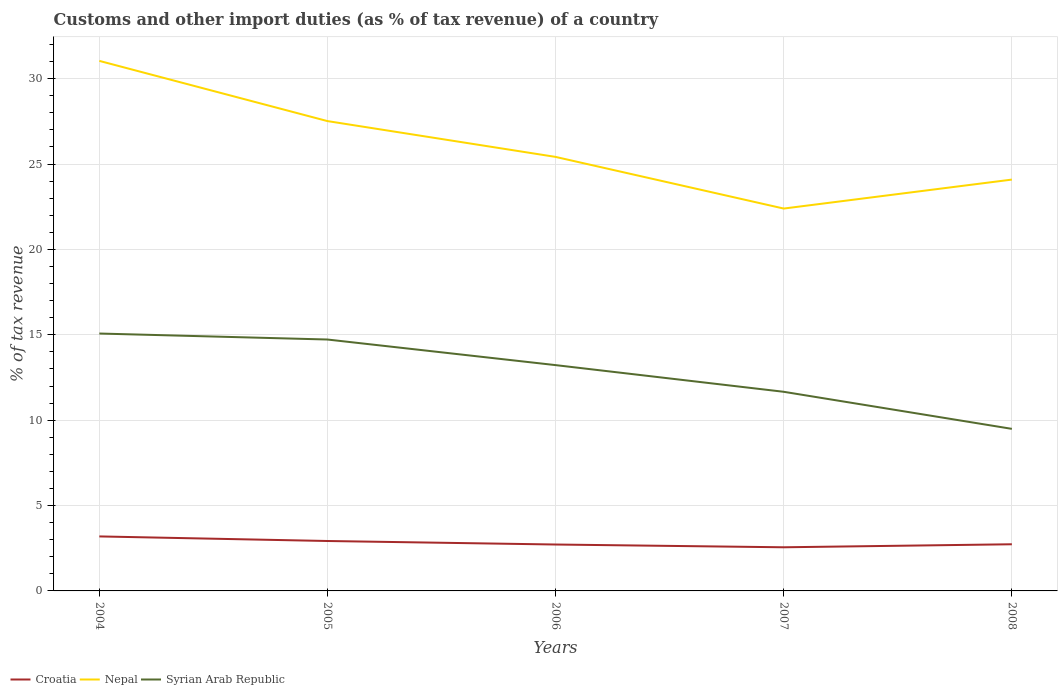Across all years, what is the maximum percentage of tax revenue from customs in Syrian Arab Republic?
Offer a terse response. 9.49. What is the total percentage of tax revenue from customs in Croatia in the graph?
Offer a terse response. 0.16. What is the difference between the highest and the second highest percentage of tax revenue from customs in Nepal?
Your answer should be very brief. 8.65. What is the difference between the highest and the lowest percentage of tax revenue from customs in Croatia?
Make the answer very short. 2. Is the percentage of tax revenue from customs in Croatia strictly greater than the percentage of tax revenue from customs in Nepal over the years?
Provide a short and direct response. Yes. What is the difference between two consecutive major ticks on the Y-axis?
Offer a terse response. 5. Are the values on the major ticks of Y-axis written in scientific E-notation?
Provide a short and direct response. No. Does the graph contain grids?
Offer a very short reply. Yes. How many legend labels are there?
Your response must be concise. 3. How are the legend labels stacked?
Offer a very short reply. Horizontal. What is the title of the graph?
Offer a terse response. Customs and other import duties (as % of tax revenue) of a country. Does "High income: nonOECD" appear as one of the legend labels in the graph?
Make the answer very short. No. What is the label or title of the Y-axis?
Make the answer very short. % of tax revenue. What is the % of tax revenue of Croatia in 2004?
Your response must be concise. 3.19. What is the % of tax revenue in Nepal in 2004?
Your answer should be very brief. 31.04. What is the % of tax revenue of Syrian Arab Republic in 2004?
Keep it short and to the point. 15.08. What is the % of tax revenue of Croatia in 2005?
Your answer should be very brief. 2.92. What is the % of tax revenue of Nepal in 2005?
Keep it short and to the point. 27.52. What is the % of tax revenue of Syrian Arab Republic in 2005?
Give a very brief answer. 14.72. What is the % of tax revenue in Croatia in 2006?
Provide a short and direct response. 2.72. What is the % of tax revenue of Nepal in 2006?
Your response must be concise. 25.42. What is the % of tax revenue of Syrian Arab Republic in 2006?
Offer a terse response. 13.22. What is the % of tax revenue in Croatia in 2007?
Offer a terse response. 2.56. What is the % of tax revenue in Nepal in 2007?
Your response must be concise. 22.39. What is the % of tax revenue of Syrian Arab Republic in 2007?
Your answer should be compact. 11.66. What is the % of tax revenue in Croatia in 2008?
Offer a terse response. 2.73. What is the % of tax revenue in Nepal in 2008?
Offer a terse response. 24.09. What is the % of tax revenue of Syrian Arab Republic in 2008?
Your answer should be very brief. 9.49. Across all years, what is the maximum % of tax revenue in Croatia?
Ensure brevity in your answer.  3.19. Across all years, what is the maximum % of tax revenue of Nepal?
Your answer should be compact. 31.04. Across all years, what is the maximum % of tax revenue in Syrian Arab Republic?
Keep it short and to the point. 15.08. Across all years, what is the minimum % of tax revenue in Croatia?
Provide a short and direct response. 2.56. Across all years, what is the minimum % of tax revenue of Nepal?
Your response must be concise. 22.39. Across all years, what is the minimum % of tax revenue of Syrian Arab Republic?
Offer a terse response. 9.49. What is the total % of tax revenue of Croatia in the graph?
Offer a terse response. 14.12. What is the total % of tax revenue of Nepal in the graph?
Your answer should be very brief. 130.47. What is the total % of tax revenue in Syrian Arab Republic in the graph?
Give a very brief answer. 64.18. What is the difference between the % of tax revenue of Croatia in 2004 and that in 2005?
Provide a succinct answer. 0.27. What is the difference between the % of tax revenue in Nepal in 2004 and that in 2005?
Ensure brevity in your answer.  3.53. What is the difference between the % of tax revenue of Syrian Arab Republic in 2004 and that in 2005?
Your response must be concise. 0.35. What is the difference between the % of tax revenue of Croatia in 2004 and that in 2006?
Provide a short and direct response. 0.47. What is the difference between the % of tax revenue of Nepal in 2004 and that in 2006?
Keep it short and to the point. 5.62. What is the difference between the % of tax revenue of Syrian Arab Republic in 2004 and that in 2006?
Your response must be concise. 1.85. What is the difference between the % of tax revenue of Croatia in 2004 and that in 2007?
Keep it short and to the point. 0.64. What is the difference between the % of tax revenue of Nepal in 2004 and that in 2007?
Offer a terse response. 8.65. What is the difference between the % of tax revenue of Syrian Arab Republic in 2004 and that in 2007?
Your answer should be compact. 3.41. What is the difference between the % of tax revenue of Croatia in 2004 and that in 2008?
Keep it short and to the point. 0.46. What is the difference between the % of tax revenue of Nepal in 2004 and that in 2008?
Make the answer very short. 6.95. What is the difference between the % of tax revenue in Syrian Arab Republic in 2004 and that in 2008?
Provide a short and direct response. 5.58. What is the difference between the % of tax revenue in Croatia in 2005 and that in 2006?
Ensure brevity in your answer.  0.21. What is the difference between the % of tax revenue in Nepal in 2005 and that in 2006?
Provide a short and direct response. 2.1. What is the difference between the % of tax revenue of Syrian Arab Republic in 2005 and that in 2006?
Provide a short and direct response. 1.5. What is the difference between the % of tax revenue in Croatia in 2005 and that in 2007?
Provide a short and direct response. 0.37. What is the difference between the % of tax revenue in Nepal in 2005 and that in 2007?
Keep it short and to the point. 5.12. What is the difference between the % of tax revenue in Syrian Arab Republic in 2005 and that in 2007?
Offer a terse response. 3.06. What is the difference between the % of tax revenue in Croatia in 2005 and that in 2008?
Your response must be concise. 0.19. What is the difference between the % of tax revenue in Nepal in 2005 and that in 2008?
Offer a very short reply. 3.43. What is the difference between the % of tax revenue in Syrian Arab Republic in 2005 and that in 2008?
Provide a succinct answer. 5.23. What is the difference between the % of tax revenue of Croatia in 2006 and that in 2007?
Offer a terse response. 0.16. What is the difference between the % of tax revenue in Nepal in 2006 and that in 2007?
Provide a short and direct response. 3.02. What is the difference between the % of tax revenue in Syrian Arab Republic in 2006 and that in 2007?
Offer a terse response. 1.56. What is the difference between the % of tax revenue of Croatia in 2006 and that in 2008?
Make the answer very short. -0.01. What is the difference between the % of tax revenue in Nepal in 2006 and that in 2008?
Provide a short and direct response. 1.33. What is the difference between the % of tax revenue in Syrian Arab Republic in 2006 and that in 2008?
Make the answer very short. 3.73. What is the difference between the % of tax revenue of Croatia in 2007 and that in 2008?
Your answer should be very brief. -0.18. What is the difference between the % of tax revenue in Nepal in 2007 and that in 2008?
Keep it short and to the point. -1.7. What is the difference between the % of tax revenue in Syrian Arab Republic in 2007 and that in 2008?
Give a very brief answer. 2.17. What is the difference between the % of tax revenue in Croatia in 2004 and the % of tax revenue in Nepal in 2005?
Your response must be concise. -24.33. What is the difference between the % of tax revenue of Croatia in 2004 and the % of tax revenue of Syrian Arab Republic in 2005?
Your response must be concise. -11.53. What is the difference between the % of tax revenue of Nepal in 2004 and the % of tax revenue of Syrian Arab Republic in 2005?
Ensure brevity in your answer.  16.32. What is the difference between the % of tax revenue in Croatia in 2004 and the % of tax revenue in Nepal in 2006?
Your answer should be very brief. -22.23. What is the difference between the % of tax revenue of Croatia in 2004 and the % of tax revenue of Syrian Arab Republic in 2006?
Give a very brief answer. -10.03. What is the difference between the % of tax revenue in Nepal in 2004 and the % of tax revenue in Syrian Arab Republic in 2006?
Make the answer very short. 17.82. What is the difference between the % of tax revenue in Croatia in 2004 and the % of tax revenue in Nepal in 2007?
Provide a succinct answer. -19.2. What is the difference between the % of tax revenue of Croatia in 2004 and the % of tax revenue of Syrian Arab Republic in 2007?
Provide a short and direct response. -8.47. What is the difference between the % of tax revenue in Nepal in 2004 and the % of tax revenue in Syrian Arab Republic in 2007?
Offer a terse response. 19.38. What is the difference between the % of tax revenue of Croatia in 2004 and the % of tax revenue of Nepal in 2008?
Your answer should be very brief. -20.9. What is the difference between the % of tax revenue in Croatia in 2004 and the % of tax revenue in Syrian Arab Republic in 2008?
Your response must be concise. -6.3. What is the difference between the % of tax revenue in Nepal in 2004 and the % of tax revenue in Syrian Arab Republic in 2008?
Make the answer very short. 21.55. What is the difference between the % of tax revenue in Croatia in 2005 and the % of tax revenue in Nepal in 2006?
Your answer should be compact. -22.5. What is the difference between the % of tax revenue in Croatia in 2005 and the % of tax revenue in Syrian Arab Republic in 2006?
Your response must be concise. -10.3. What is the difference between the % of tax revenue in Nepal in 2005 and the % of tax revenue in Syrian Arab Republic in 2006?
Keep it short and to the point. 14.29. What is the difference between the % of tax revenue in Croatia in 2005 and the % of tax revenue in Nepal in 2007?
Provide a succinct answer. -19.47. What is the difference between the % of tax revenue of Croatia in 2005 and the % of tax revenue of Syrian Arab Republic in 2007?
Offer a terse response. -8.74. What is the difference between the % of tax revenue of Nepal in 2005 and the % of tax revenue of Syrian Arab Republic in 2007?
Give a very brief answer. 15.85. What is the difference between the % of tax revenue in Croatia in 2005 and the % of tax revenue in Nepal in 2008?
Offer a terse response. -21.17. What is the difference between the % of tax revenue in Croatia in 2005 and the % of tax revenue in Syrian Arab Republic in 2008?
Provide a succinct answer. -6.57. What is the difference between the % of tax revenue of Nepal in 2005 and the % of tax revenue of Syrian Arab Republic in 2008?
Provide a short and direct response. 18.03. What is the difference between the % of tax revenue of Croatia in 2006 and the % of tax revenue of Nepal in 2007?
Give a very brief answer. -19.68. What is the difference between the % of tax revenue of Croatia in 2006 and the % of tax revenue of Syrian Arab Republic in 2007?
Your answer should be compact. -8.95. What is the difference between the % of tax revenue in Nepal in 2006 and the % of tax revenue in Syrian Arab Republic in 2007?
Provide a succinct answer. 13.76. What is the difference between the % of tax revenue of Croatia in 2006 and the % of tax revenue of Nepal in 2008?
Give a very brief answer. -21.37. What is the difference between the % of tax revenue of Croatia in 2006 and the % of tax revenue of Syrian Arab Republic in 2008?
Your response must be concise. -6.77. What is the difference between the % of tax revenue in Nepal in 2006 and the % of tax revenue in Syrian Arab Republic in 2008?
Your answer should be very brief. 15.93. What is the difference between the % of tax revenue of Croatia in 2007 and the % of tax revenue of Nepal in 2008?
Provide a short and direct response. -21.54. What is the difference between the % of tax revenue of Croatia in 2007 and the % of tax revenue of Syrian Arab Republic in 2008?
Keep it short and to the point. -6.94. What is the difference between the % of tax revenue in Nepal in 2007 and the % of tax revenue in Syrian Arab Republic in 2008?
Offer a very short reply. 12.9. What is the average % of tax revenue of Croatia per year?
Provide a short and direct response. 2.82. What is the average % of tax revenue in Nepal per year?
Keep it short and to the point. 26.09. What is the average % of tax revenue of Syrian Arab Republic per year?
Ensure brevity in your answer.  12.84. In the year 2004, what is the difference between the % of tax revenue in Croatia and % of tax revenue in Nepal?
Keep it short and to the point. -27.85. In the year 2004, what is the difference between the % of tax revenue in Croatia and % of tax revenue in Syrian Arab Republic?
Offer a terse response. -11.88. In the year 2004, what is the difference between the % of tax revenue of Nepal and % of tax revenue of Syrian Arab Republic?
Offer a very short reply. 15.97. In the year 2005, what is the difference between the % of tax revenue in Croatia and % of tax revenue in Nepal?
Offer a very short reply. -24.59. In the year 2005, what is the difference between the % of tax revenue in Croatia and % of tax revenue in Syrian Arab Republic?
Offer a very short reply. -11.8. In the year 2005, what is the difference between the % of tax revenue of Nepal and % of tax revenue of Syrian Arab Republic?
Your answer should be very brief. 12.79. In the year 2006, what is the difference between the % of tax revenue of Croatia and % of tax revenue of Nepal?
Your answer should be very brief. -22.7. In the year 2006, what is the difference between the % of tax revenue of Croatia and % of tax revenue of Syrian Arab Republic?
Offer a very short reply. -10.51. In the year 2006, what is the difference between the % of tax revenue in Nepal and % of tax revenue in Syrian Arab Republic?
Give a very brief answer. 12.19. In the year 2007, what is the difference between the % of tax revenue in Croatia and % of tax revenue in Nepal?
Provide a succinct answer. -19.84. In the year 2007, what is the difference between the % of tax revenue in Croatia and % of tax revenue in Syrian Arab Republic?
Your response must be concise. -9.11. In the year 2007, what is the difference between the % of tax revenue in Nepal and % of tax revenue in Syrian Arab Republic?
Your response must be concise. 10.73. In the year 2008, what is the difference between the % of tax revenue of Croatia and % of tax revenue of Nepal?
Keep it short and to the point. -21.36. In the year 2008, what is the difference between the % of tax revenue of Croatia and % of tax revenue of Syrian Arab Republic?
Ensure brevity in your answer.  -6.76. In the year 2008, what is the difference between the % of tax revenue of Nepal and % of tax revenue of Syrian Arab Republic?
Provide a succinct answer. 14.6. What is the ratio of the % of tax revenue in Croatia in 2004 to that in 2005?
Provide a succinct answer. 1.09. What is the ratio of the % of tax revenue in Nepal in 2004 to that in 2005?
Your answer should be compact. 1.13. What is the ratio of the % of tax revenue in Syrian Arab Republic in 2004 to that in 2005?
Give a very brief answer. 1.02. What is the ratio of the % of tax revenue in Croatia in 2004 to that in 2006?
Ensure brevity in your answer.  1.17. What is the ratio of the % of tax revenue in Nepal in 2004 to that in 2006?
Give a very brief answer. 1.22. What is the ratio of the % of tax revenue of Syrian Arab Republic in 2004 to that in 2006?
Offer a very short reply. 1.14. What is the ratio of the % of tax revenue in Croatia in 2004 to that in 2007?
Provide a short and direct response. 1.25. What is the ratio of the % of tax revenue of Nepal in 2004 to that in 2007?
Your answer should be very brief. 1.39. What is the ratio of the % of tax revenue of Syrian Arab Republic in 2004 to that in 2007?
Offer a terse response. 1.29. What is the ratio of the % of tax revenue of Croatia in 2004 to that in 2008?
Make the answer very short. 1.17. What is the ratio of the % of tax revenue in Nepal in 2004 to that in 2008?
Provide a succinct answer. 1.29. What is the ratio of the % of tax revenue in Syrian Arab Republic in 2004 to that in 2008?
Provide a short and direct response. 1.59. What is the ratio of the % of tax revenue in Croatia in 2005 to that in 2006?
Make the answer very short. 1.08. What is the ratio of the % of tax revenue of Nepal in 2005 to that in 2006?
Keep it short and to the point. 1.08. What is the ratio of the % of tax revenue in Syrian Arab Republic in 2005 to that in 2006?
Give a very brief answer. 1.11. What is the ratio of the % of tax revenue of Croatia in 2005 to that in 2007?
Your response must be concise. 1.14. What is the ratio of the % of tax revenue in Nepal in 2005 to that in 2007?
Make the answer very short. 1.23. What is the ratio of the % of tax revenue in Syrian Arab Republic in 2005 to that in 2007?
Your response must be concise. 1.26. What is the ratio of the % of tax revenue of Croatia in 2005 to that in 2008?
Make the answer very short. 1.07. What is the ratio of the % of tax revenue in Nepal in 2005 to that in 2008?
Keep it short and to the point. 1.14. What is the ratio of the % of tax revenue of Syrian Arab Republic in 2005 to that in 2008?
Ensure brevity in your answer.  1.55. What is the ratio of the % of tax revenue in Croatia in 2006 to that in 2007?
Offer a terse response. 1.06. What is the ratio of the % of tax revenue in Nepal in 2006 to that in 2007?
Keep it short and to the point. 1.14. What is the ratio of the % of tax revenue of Syrian Arab Republic in 2006 to that in 2007?
Ensure brevity in your answer.  1.13. What is the ratio of the % of tax revenue of Nepal in 2006 to that in 2008?
Provide a short and direct response. 1.06. What is the ratio of the % of tax revenue of Syrian Arab Republic in 2006 to that in 2008?
Your answer should be compact. 1.39. What is the ratio of the % of tax revenue in Croatia in 2007 to that in 2008?
Keep it short and to the point. 0.94. What is the ratio of the % of tax revenue of Nepal in 2007 to that in 2008?
Keep it short and to the point. 0.93. What is the ratio of the % of tax revenue in Syrian Arab Republic in 2007 to that in 2008?
Keep it short and to the point. 1.23. What is the difference between the highest and the second highest % of tax revenue in Croatia?
Make the answer very short. 0.27. What is the difference between the highest and the second highest % of tax revenue of Nepal?
Give a very brief answer. 3.53. What is the difference between the highest and the second highest % of tax revenue in Syrian Arab Republic?
Ensure brevity in your answer.  0.35. What is the difference between the highest and the lowest % of tax revenue in Croatia?
Offer a very short reply. 0.64. What is the difference between the highest and the lowest % of tax revenue in Nepal?
Your answer should be compact. 8.65. What is the difference between the highest and the lowest % of tax revenue in Syrian Arab Republic?
Give a very brief answer. 5.58. 